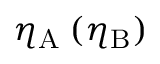<formula> <loc_0><loc_0><loc_500><loc_500>\eta _ { A } \, ( \eta _ { B } )</formula> 